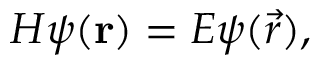Convert formula to latex. <formula><loc_0><loc_0><loc_500><loc_500>H \psi ( r ) = E \psi ( \vec { r } ) ,</formula> 